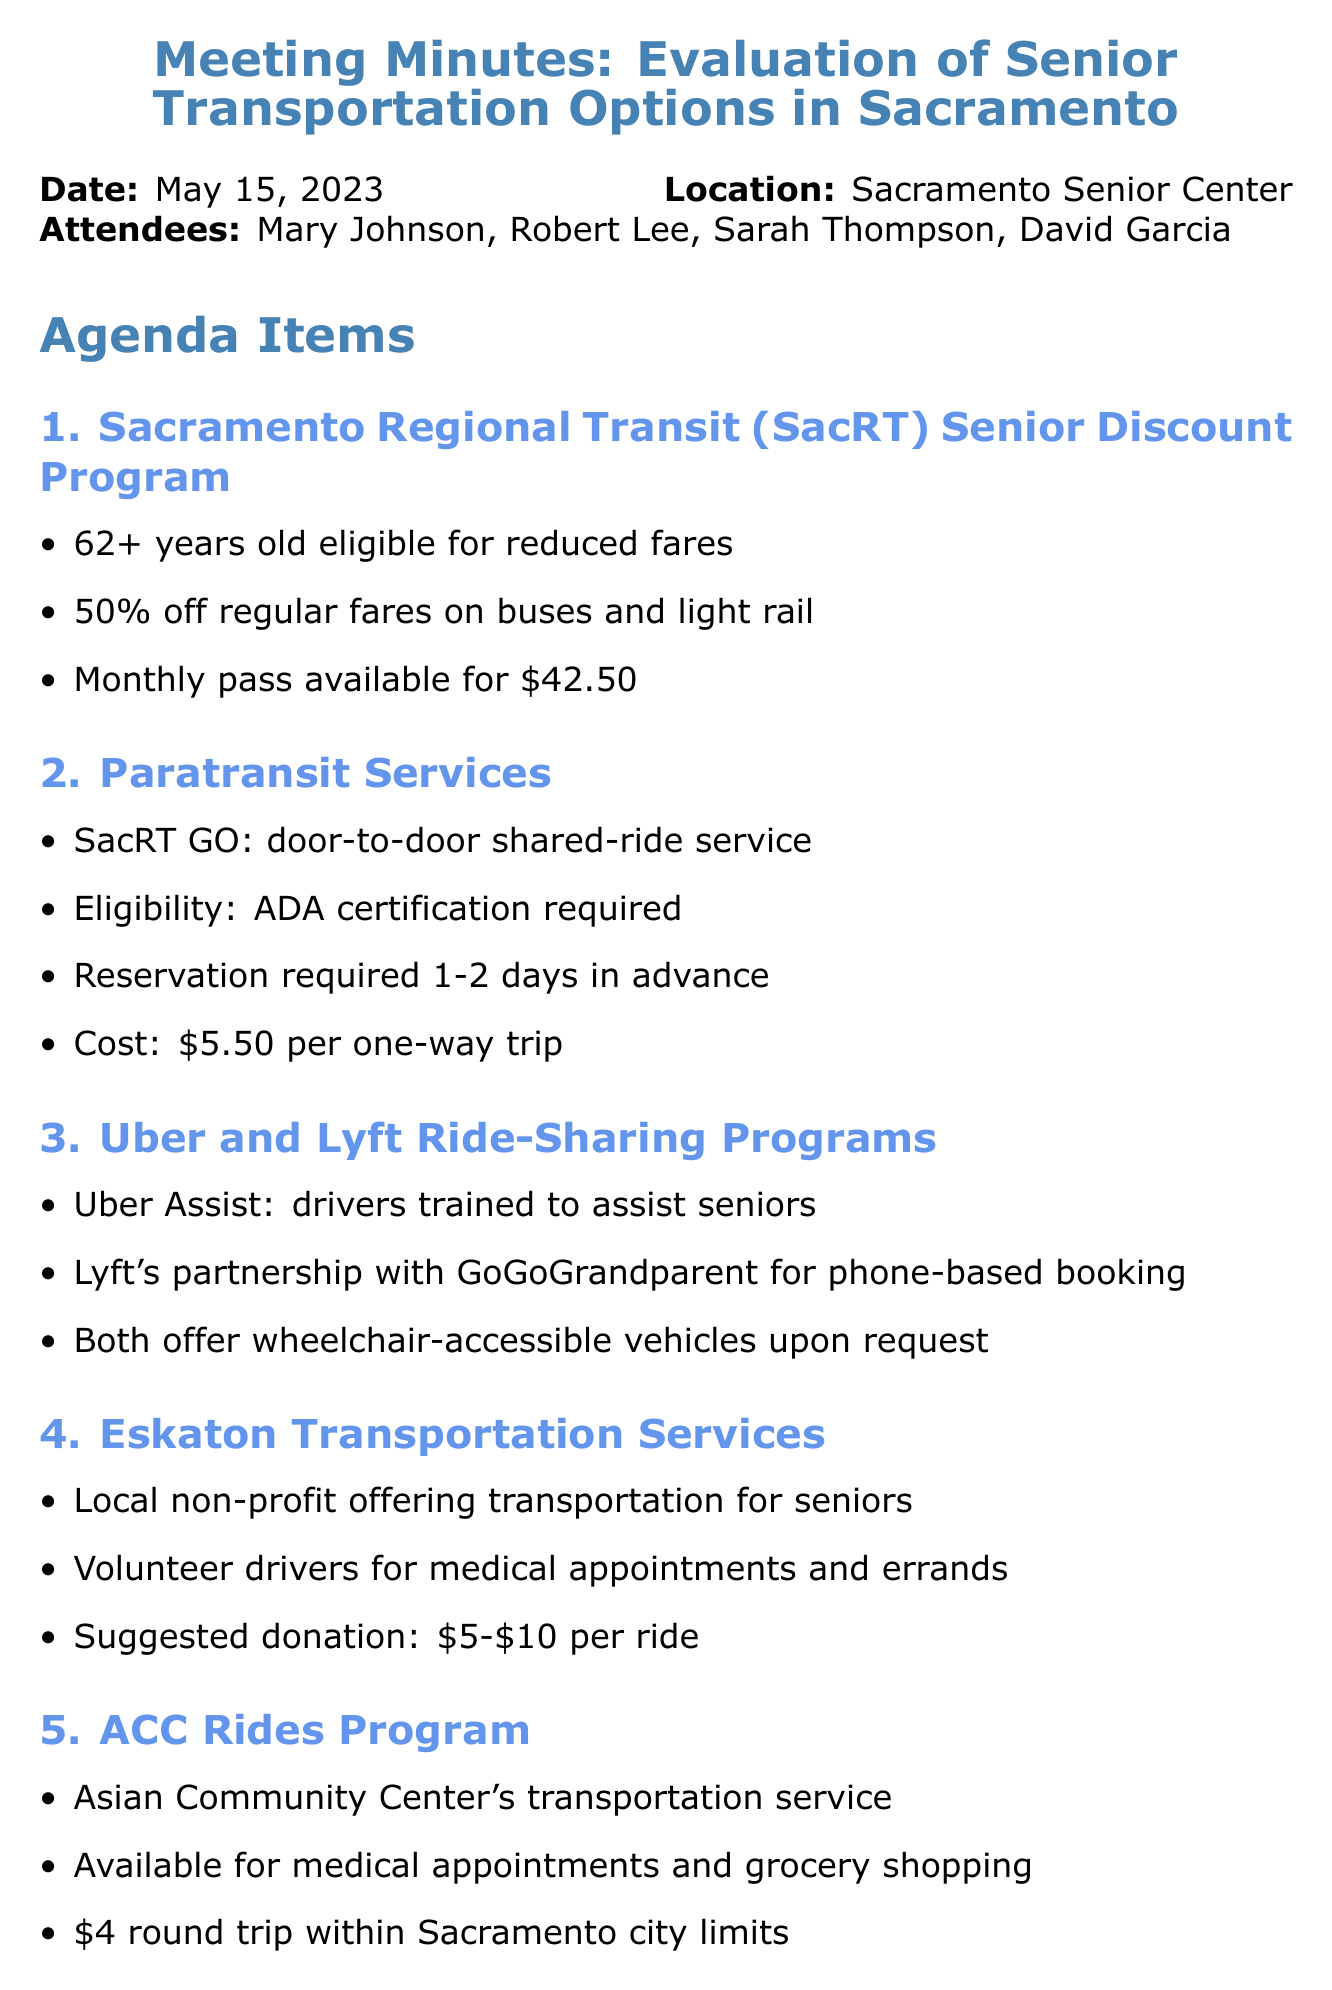What is the date of the meeting? The date of the meeting is specified in the document.
Answer: May 15, 2023 Who are the attendees listed in the meeting? The document lists the names of the attendees at the meeting.
Answer: Mary Johnson, Robert Lee, Sarah Thompson, David Garcia What is the cost of a one-way trip for Paratransit Services? The document provides the cost for Paratransit Services in the details section.
Answer: $5.50 How much is the suggested donation for Eskaton Transportation Services? The document specifies the suggested donation amount for Eskaton Transportation Services.
Answer: $5-$10 What is the monthly pass cost for SacRT Senior Discount Program? The document mentions the cost of a monthly pass under the Sacramento Regional Transit Senior Discount Program.
Answer: $42.50 What transportation service is available for grocery shopping according to ACC Rides Program? The document indicates what types of appointments ACC Rides Program covers.
Answer: Grocery shopping What is required for Paratransit Services eligibility? The eligibility criteria for Paratransit Services is stated in the document.
Answer: ADA certification What is the next meeting date? The next meeting date is mentioned at the end of the document.
Answer: June 12, 2023 